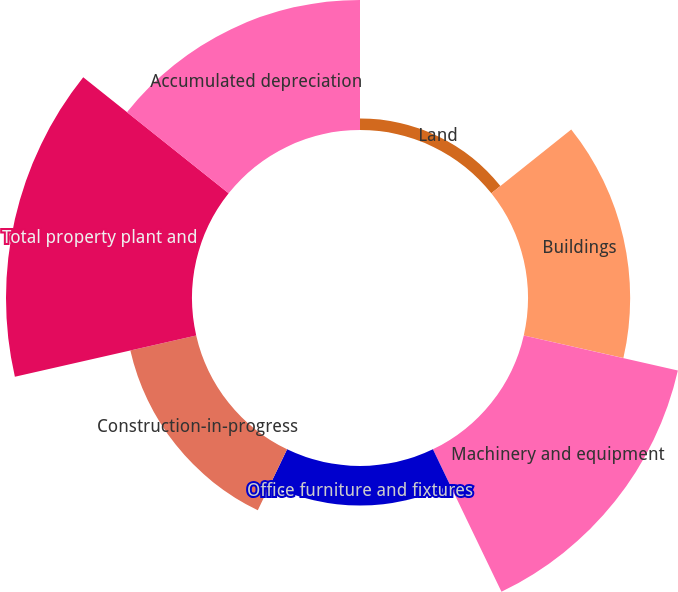<chart> <loc_0><loc_0><loc_500><loc_500><pie_chart><fcel>Land<fcel>Buildings<fcel>Machinery and equipment<fcel>Office furniture and fixtures<fcel>Construction-in-progress<fcel>Total property plant and<fcel>Accumulated depreciation<nl><fcel>1.67%<fcel>14.7%<fcel>22.74%<fcel>5.69%<fcel>9.72%<fcel>26.76%<fcel>18.72%<nl></chart> 